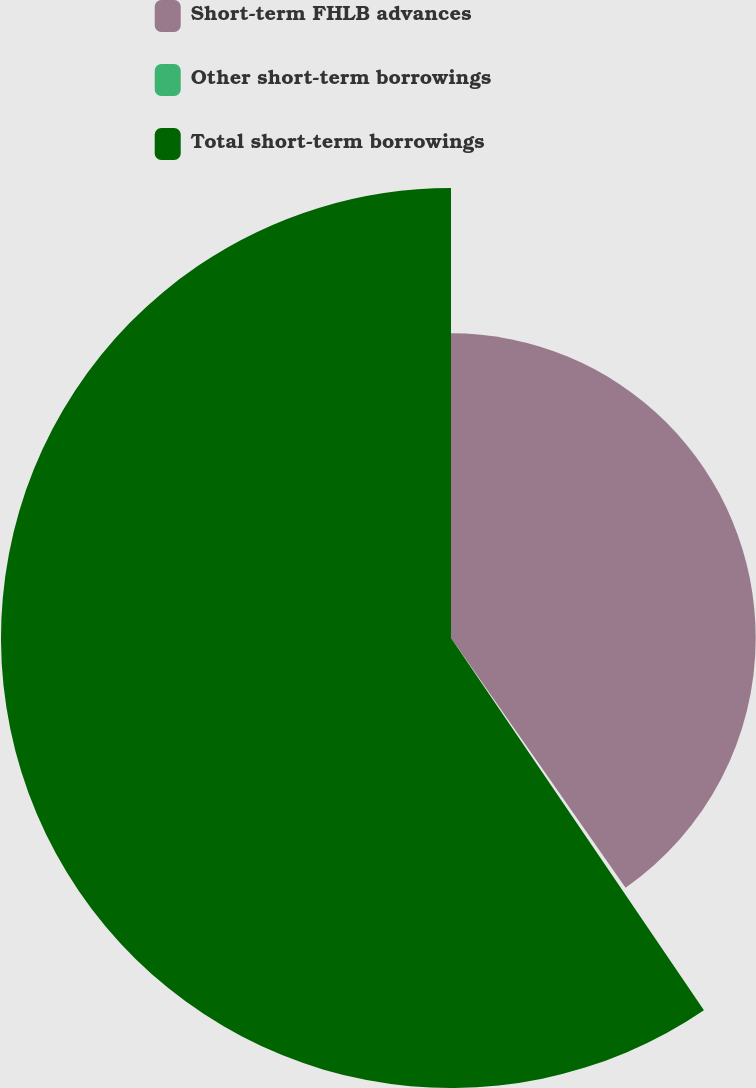Convert chart. <chart><loc_0><loc_0><loc_500><loc_500><pie_chart><fcel>Short-term FHLB advances<fcel>Other short-term borrowings<fcel>Total short-term borrowings<nl><fcel>40.29%<fcel>0.21%<fcel>59.5%<nl></chart> 